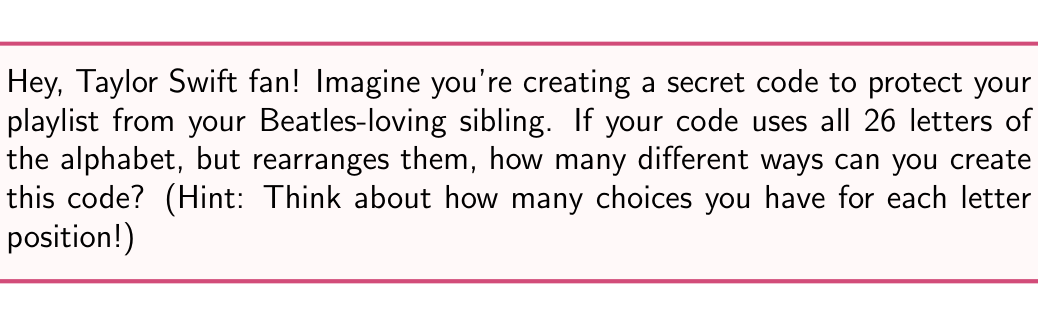Can you answer this question? Alright, let's break this down step-by-step:

1) In this scenario, we're essentially creating a substitution cipher, where each letter of the alphabet is replaced by another letter.

2) For the first letter in our cipher alphabet, we have 26 choices (all 26 letters of the alphabet).

3) For the second letter, we now have 25 choices, because we can't use the letter we used for the first position.

4) For the third letter, we have 24 choices, and so on.

5) This pattern continues until we place the last letter, for which we'll have only 1 choice left.

6) In mathematical terms, this is a permutation of 26 objects, which is represented by 26! (26 factorial).

7) The formula for this is:

   $$26! = 26 \times 25 \times 24 \times 23 \times ... \times 3 \times 2 \times 1$$

8) Calculating this out:
   
   $$26! = 403,291,461,126,605,635,584,000,000$$

This incredibly large number represents the total number of possible encryption keys for a substitution cipher using a 26-letter alphabet.
Answer: $26!$ or 403,291,461,126,605,635,584,000,000 